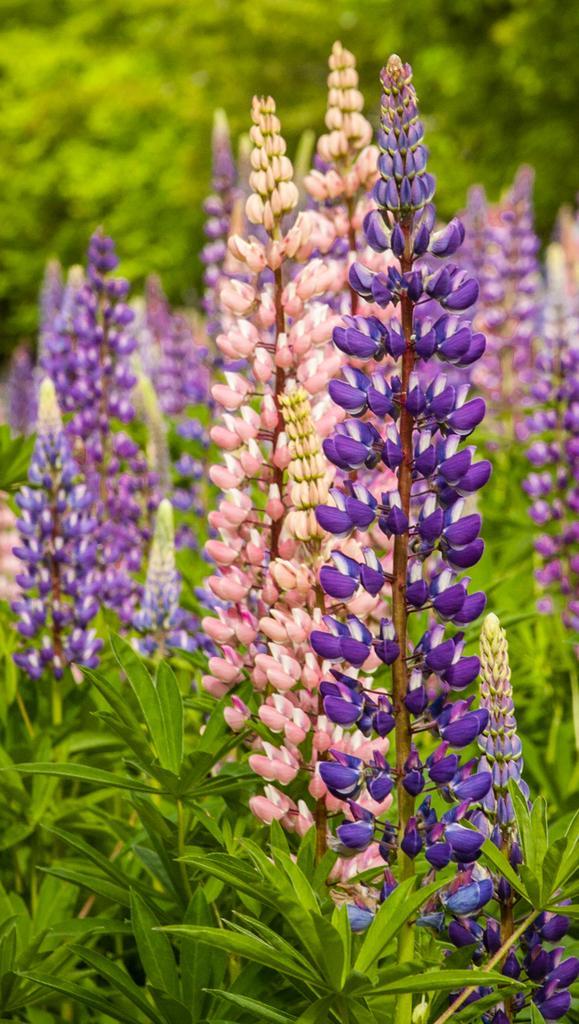Could you give a brief overview of what you see in this image? In this image we can see few plants and there are group of flowers to the plants. In the background, we can see the trees. 